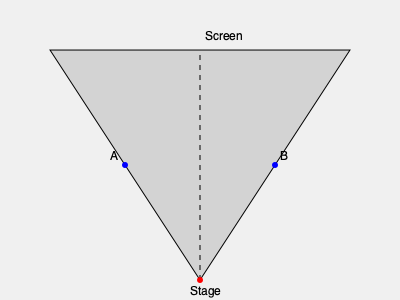In a comedy club, you're setting up the stage for your next show with Mace & Burton. The diagram shows a top-down view of the theater. If the stage is 40 feet wide and the distance from the stage to the screen is 60 feet, what's the difference in viewing angles between audience members A and B, who are sitting halfway between the stage and the screen? Let's approach this step-by-step:

1) First, we need to calculate the viewing angle for each audience member. The viewing angle is the angle formed between the lines from the audience member to the left and right edges of the stage.

2) For audience member A:
   - The triangle formed is a right triangle.
   - The base of this triangle is half the stage width: 40/2 = 20 feet
   - The height of the triangle is half the distance to the screen: 60/2 = 30 feet
   - We can calculate the angle using arctangent: $\theta_A = 2 \times \arctan(\frac{20}{30})$

3) For audience member B:
   - It's the same calculation, but mirrored: $\theta_B = 2 \times \arctan(\frac{20}{30})$

4) Calculate the angles:
   $\theta_A = \theta_B = 2 \times \arctan(\frac{20}{30}) \approx 67.38°$

5) The difference in viewing angles:
   $\Delta\theta = |\theta_A - \theta_B| = 67.38° - 67.38° = 0°$

The viewing angles are the same for both audience members due to symmetry.
Answer: 0° 